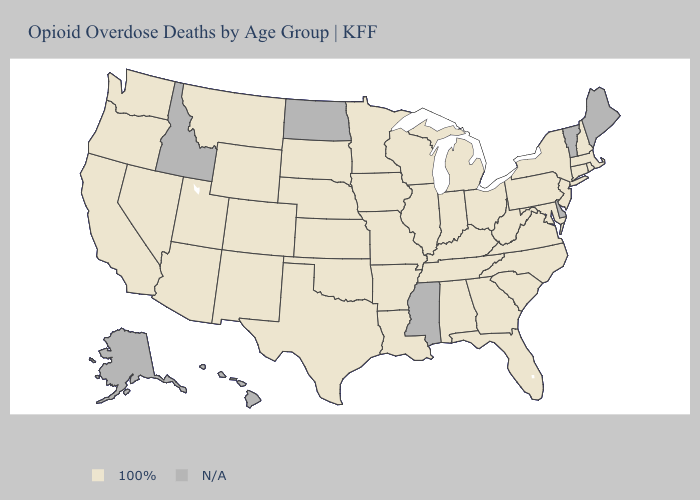Name the states that have a value in the range N/A?
Quick response, please. Alaska, Delaware, Hawaii, Idaho, Maine, Mississippi, North Dakota, Vermont. Among the states that border Wyoming , which have the lowest value?
Keep it brief. Colorado, Montana, Nebraska, South Dakota, Utah. Which states have the lowest value in the Northeast?
Answer briefly. Connecticut, Massachusetts, New Hampshire, New Jersey, New York, Pennsylvania, Rhode Island. Name the states that have a value in the range N/A?
Write a very short answer. Alaska, Delaware, Hawaii, Idaho, Maine, Mississippi, North Dakota, Vermont. Does the first symbol in the legend represent the smallest category?
Quick response, please. No. What is the highest value in states that border Louisiana?
Answer briefly. 100%. Which states have the lowest value in the Northeast?
Concise answer only. Connecticut, Massachusetts, New Hampshire, New Jersey, New York, Pennsylvania, Rhode Island. Name the states that have a value in the range 100%?
Keep it brief. Alabama, Arizona, Arkansas, California, Colorado, Connecticut, Florida, Georgia, Illinois, Indiana, Iowa, Kansas, Kentucky, Louisiana, Maryland, Massachusetts, Michigan, Minnesota, Missouri, Montana, Nebraska, Nevada, New Hampshire, New Jersey, New Mexico, New York, North Carolina, Ohio, Oklahoma, Oregon, Pennsylvania, Rhode Island, South Carolina, South Dakota, Tennessee, Texas, Utah, Virginia, Washington, West Virginia, Wisconsin, Wyoming. What is the value of Kentucky?
Concise answer only. 100%. What is the lowest value in the USA?
Concise answer only. 100%. What is the lowest value in the Northeast?
Quick response, please. 100%. Among the states that border New Jersey , which have the lowest value?
Quick response, please. New York, Pennsylvania. Which states have the highest value in the USA?
Write a very short answer. Alabama, Arizona, Arkansas, California, Colorado, Connecticut, Florida, Georgia, Illinois, Indiana, Iowa, Kansas, Kentucky, Louisiana, Maryland, Massachusetts, Michigan, Minnesota, Missouri, Montana, Nebraska, Nevada, New Hampshire, New Jersey, New Mexico, New York, North Carolina, Ohio, Oklahoma, Oregon, Pennsylvania, Rhode Island, South Carolina, South Dakota, Tennessee, Texas, Utah, Virginia, Washington, West Virginia, Wisconsin, Wyoming. Does the first symbol in the legend represent the smallest category?
Short answer required. No. 